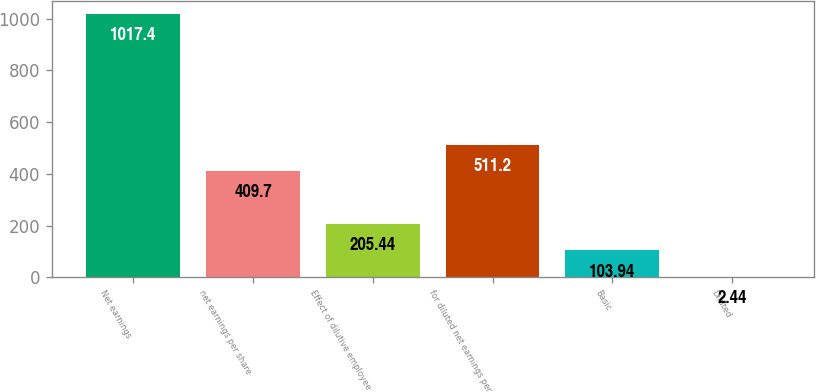Convert chart to OTSL. <chart><loc_0><loc_0><loc_500><loc_500><bar_chart><fcel>Net earnings<fcel>net earnings per share<fcel>Effect of dilutive employee<fcel>for diluted net earnings per<fcel>Basic<fcel>Diluted<nl><fcel>1017.4<fcel>409.7<fcel>205.44<fcel>511.2<fcel>103.94<fcel>2.44<nl></chart> 